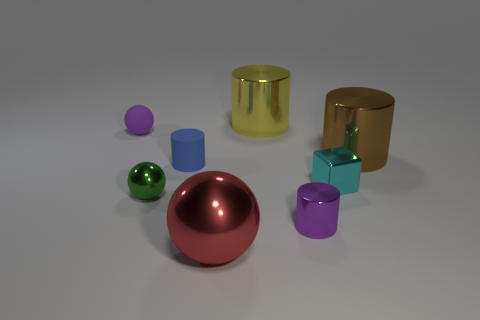Subtract all big red balls. How many balls are left? 2 Add 1 blue matte cylinders. How many objects exist? 9 Subtract all purple cylinders. How many cylinders are left? 3 Subtract all balls. How many objects are left? 5 Subtract all tiny purple objects. Subtract all tiny green spheres. How many objects are left? 5 Add 7 small rubber objects. How many small rubber objects are left? 9 Add 3 matte cylinders. How many matte cylinders exist? 4 Subtract 1 purple balls. How many objects are left? 7 Subtract all red cylinders. Subtract all green balls. How many cylinders are left? 4 